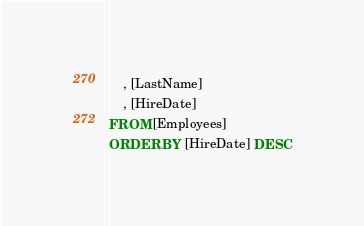<code> <loc_0><loc_0><loc_500><loc_500><_SQL_>	, [LastName]
	, [HireDate]
FROM [Employees]
ORDER BY [HireDate] DESC
</code> 